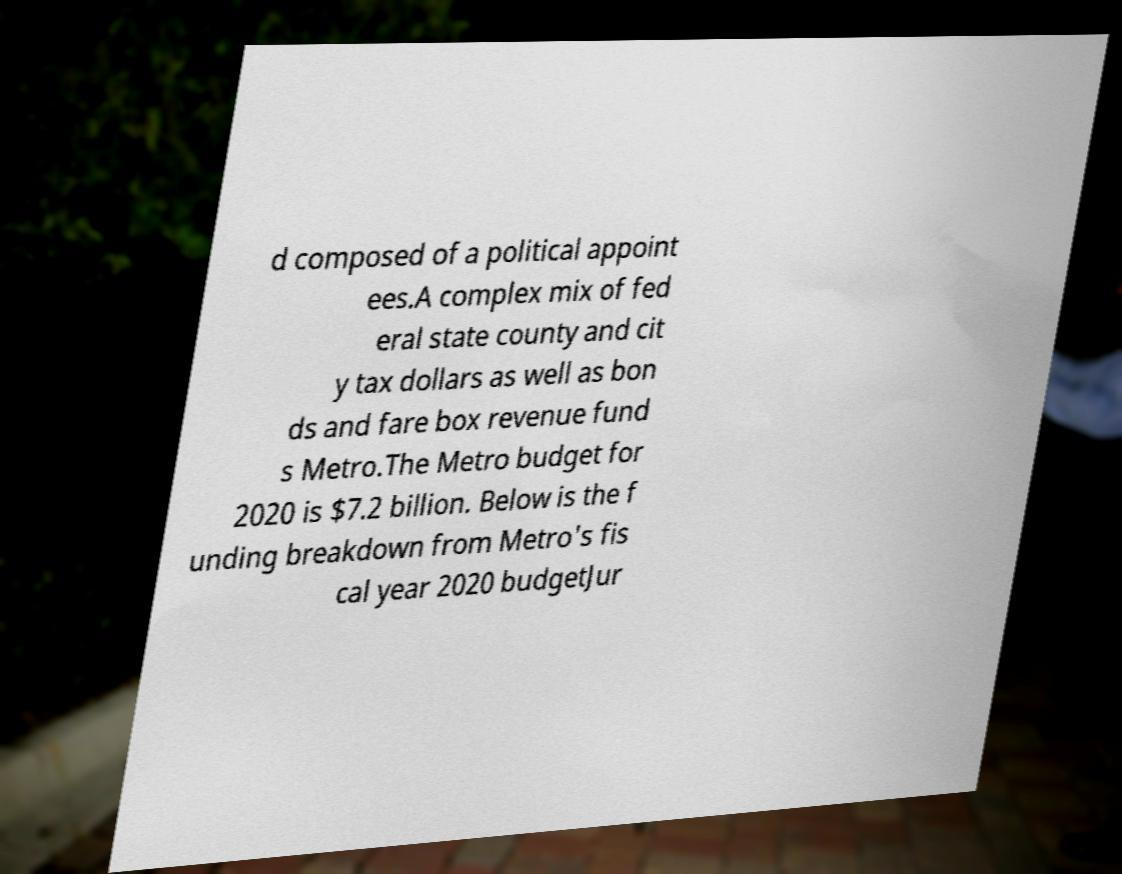For documentation purposes, I need the text within this image transcribed. Could you provide that? d composed of a political appoint ees.A complex mix of fed eral state county and cit y tax dollars as well as bon ds and fare box revenue fund s Metro.The Metro budget for 2020 is $7.2 billion. Below is the f unding breakdown from Metro's fis cal year 2020 budgetJur 